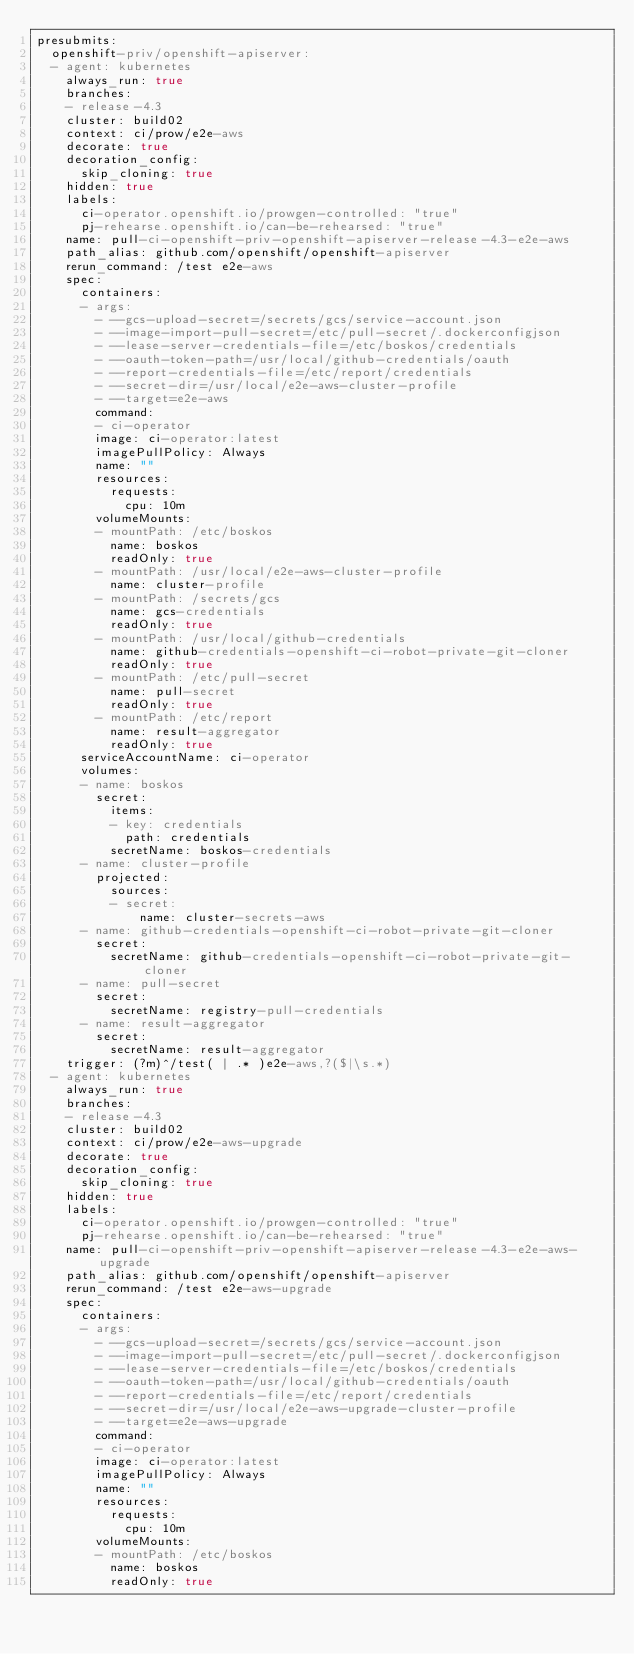<code> <loc_0><loc_0><loc_500><loc_500><_YAML_>presubmits:
  openshift-priv/openshift-apiserver:
  - agent: kubernetes
    always_run: true
    branches:
    - release-4.3
    cluster: build02
    context: ci/prow/e2e-aws
    decorate: true
    decoration_config:
      skip_cloning: true
    hidden: true
    labels:
      ci-operator.openshift.io/prowgen-controlled: "true"
      pj-rehearse.openshift.io/can-be-rehearsed: "true"
    name: pull-ci-openshift-priv-openshift-apiserver-release-4.3-e2e-aws
    path_alias: github.com/openshift/openshift-apiserver
    rerun_command: /test e2e-aws
    spec:
      containers:
      - args:
        - --gcs-upload-secret=/secrets/gcs/service-account.json
        - --image-import-pull-secret=/etc/pull-secret/.dockerconfigjson
        - --lease-server-credentials-file=/etc/boskos/credentials
        - --oauth-token-path=/usr/local/github-credentials/oauth
        - --report-credentials-file=/etc/report/credentials
        - --secret-dir=/usr/local/e2e-aws-cluster-profile
        - --target=e2e-aws
        command:
        - ci-operator
        image: ci-operator:latest
        imagePullPolicy: Always
        name: ""
        resources:
          requests:
            cpu: 10m
        volumeMounts:
        - mountPath: /etc/boskos
          name: boskos
          readOnly: true
        - mountPath: /usr/local/e2e-aws-cluster-profile
          name: cluster-profile
        - mountPath: /secrets/gcs
          name: gcs-credentials
          readOnly: true
        - mountPath: /usr/local/github-credentials
          name: github-credentials-openshift-ci-robot-private-git-cloner
          readOnly: true
        - mountPath: /etc/pull-secret
          name: pull-secret
          readOnly: true
        - mountPath: /etc/report
          name: result-aggregator
          readOnly: true
      serviceAccountName: ci-operator
      volumes:
      - name: boskos
        secret:
          items:
          - key: credentials
            path: credentials
          secretName: boskos-credentials
      - name: cluster-profile
        projected:
          sources:
          - secret:
              name: cluster-secrets-aws
      - name: github-credentials-openshift-ci-robot-private-git-cloner
        secret:
          secretName: github-credentials-openshift-ci-robot-private-git-cloner
      - name: pull-secret
        secret:
          secretName: registry-pull-credentials
      - name: result-aggregator
        secret:
          secretName: result-aggregator
    trigger: (?m)^/test( | .* )e2e-aws,?($|\s.*)
  - agent: kubernetes
    always_run: true
    branches:
    - release-4.3
    cluster: build02
    context: ci/prow/e2e-aws-upgrade
    decorate: true
    decoration_config:
      skip_cloning: true
    hidden: true
    labels:
      ci-operator.openshift.io/prowgen-controlled: "true"
      pj-rehearse.openshift.io/can-be-rehearsed: "true"
    name: pull-ci-openshift-priv-openshift-apiserver-release-4.3-e2e-aws-upgrade
    path_alias: github.com/openshift/openshift-apiserver
    rerun_command: /test e2e-aws-upgrade
    spec:
      containers:
      - args:
        - --gcs-upload-secret=/secrets/gcs/service-account.json
        - --image-import-pull-secret=/etc/pull-secret/.dockerconfigjson
        - --lease-server-credentials-file=/etc/boskos/credentials
        - --oauth-token-path=/usr/local/github-credentials/oauth
        - --report-credentials-file=/etc/report/credentials
        - --secret-dir=/usr/local/e2e-aws-upgrade-cluster-profile
        - --target=e2e-aws-upgrade
        command:
        - ci-operator
        image: ci-operator:latest
        imagePullPolicy: Always
        name: ""
        resources:
          requests:
            cpu: 10m
        volumeMounts:
        - mountPath: /etc/boskos
          name: boskos
          readOnly: true</code> 